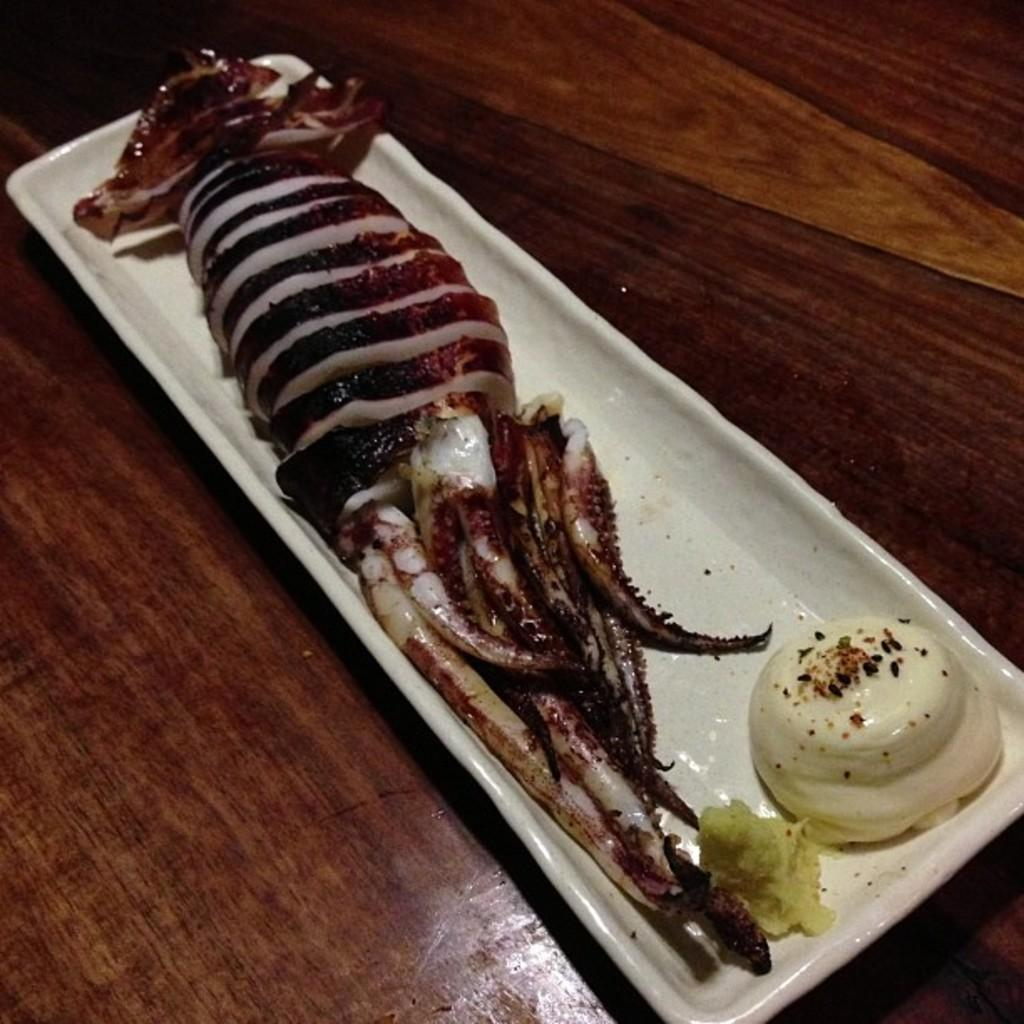What is located in the center of the image? There is a platform in the center of the image. What can be seen on top of the platform? There is a white color object on the platform. What is inside the white object? The white object contains food items. How many cherries can be seen on the tiger in the image? There is no tiger or cherry present in the image. What type of apple is visible on the platform in the image? There is no apple present in the image; the white object contains food items, but no specific items are mentioned. 